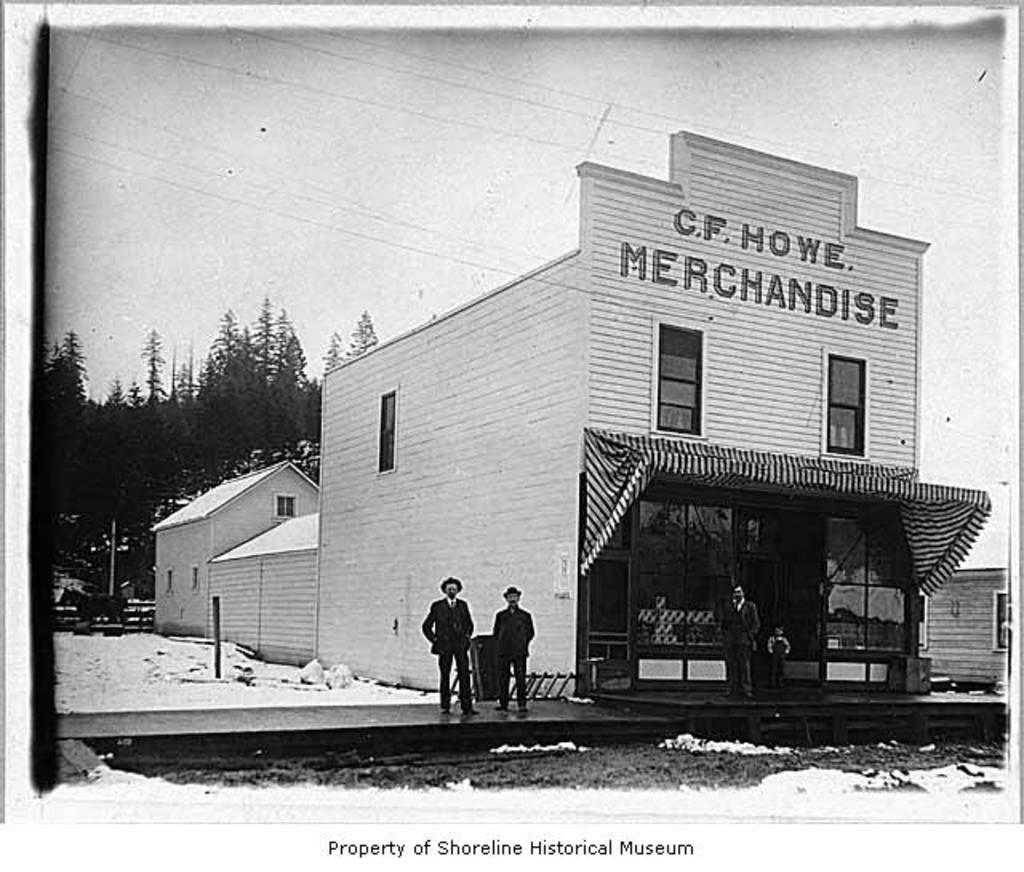What is the color scheme of the image? The image is in black and white. What type of structure is present in the image? There is a building in the image. What feature can be observed on the building? The building has windows. Are there any people in the image? Yes, there are persons standing in the image. What type of natural elements are present in the image? There are trees and snow in the image. What is visible in the background of the image? There is a sky visible in the image. What discovery was made by the persons standing in the image? There is no indication of a discovery being made in the image; it simply shows persons standing near a building. What action are the persons in the image performing? The image does not show any specific action being performed by the persons; they are simply standing. 